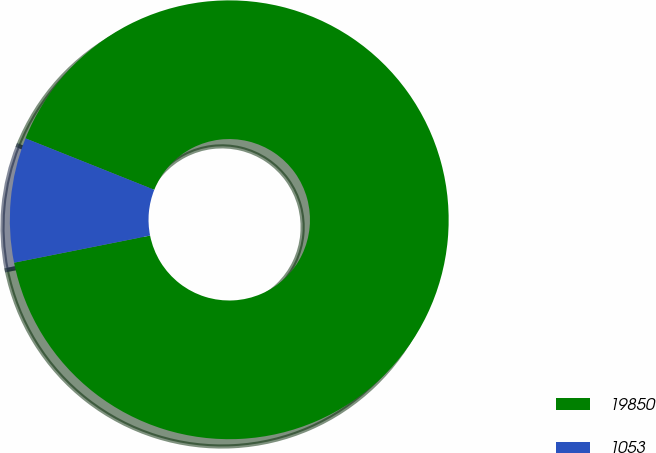<chart> <loc_0><loc_0><loc_500><loc_500><pie_chart><fcel>19850<fcel>1053<nl><fcel>90.82%<fcel>9.18%<nl></chart> 